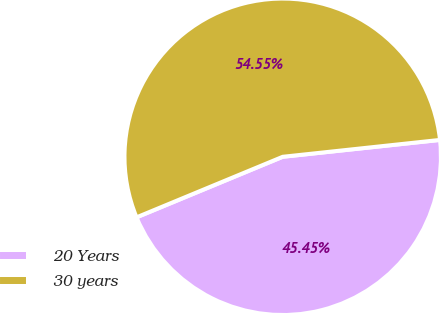Convert chart to OTSL. <chart><loc_0><loc_0><loc_500><loc_500><pie_chart><fcel>20 Years<fcel>30 years<nl><fcel>45.45%<fcel>54.55%<nl></chart> 